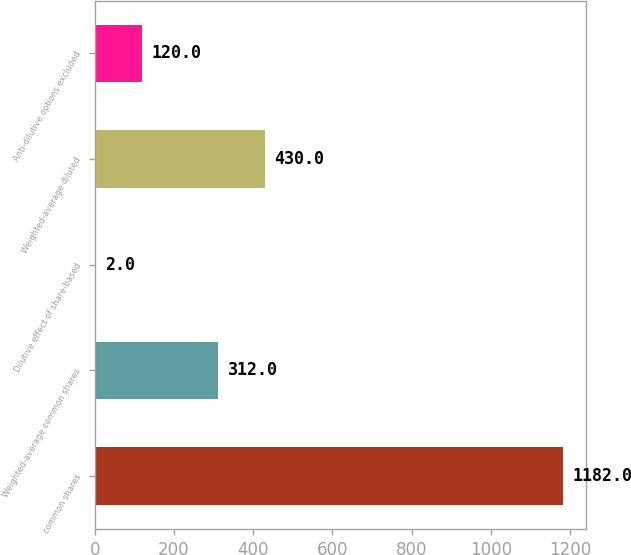Convert chart to OTSL. <chart><loc_0><loc_0><loc_500><loc_500><bar_chart><fcel>common shares<fcel>Weighted-average common shares<fcel>Dilutive effect of share-based<fcel>Weighted-average diluted<fcel>Anti-dilutive options excluded<nl><fcel>1182<fcel>312<fcel>2<fcel>430<fcel>120<nl></chart> 